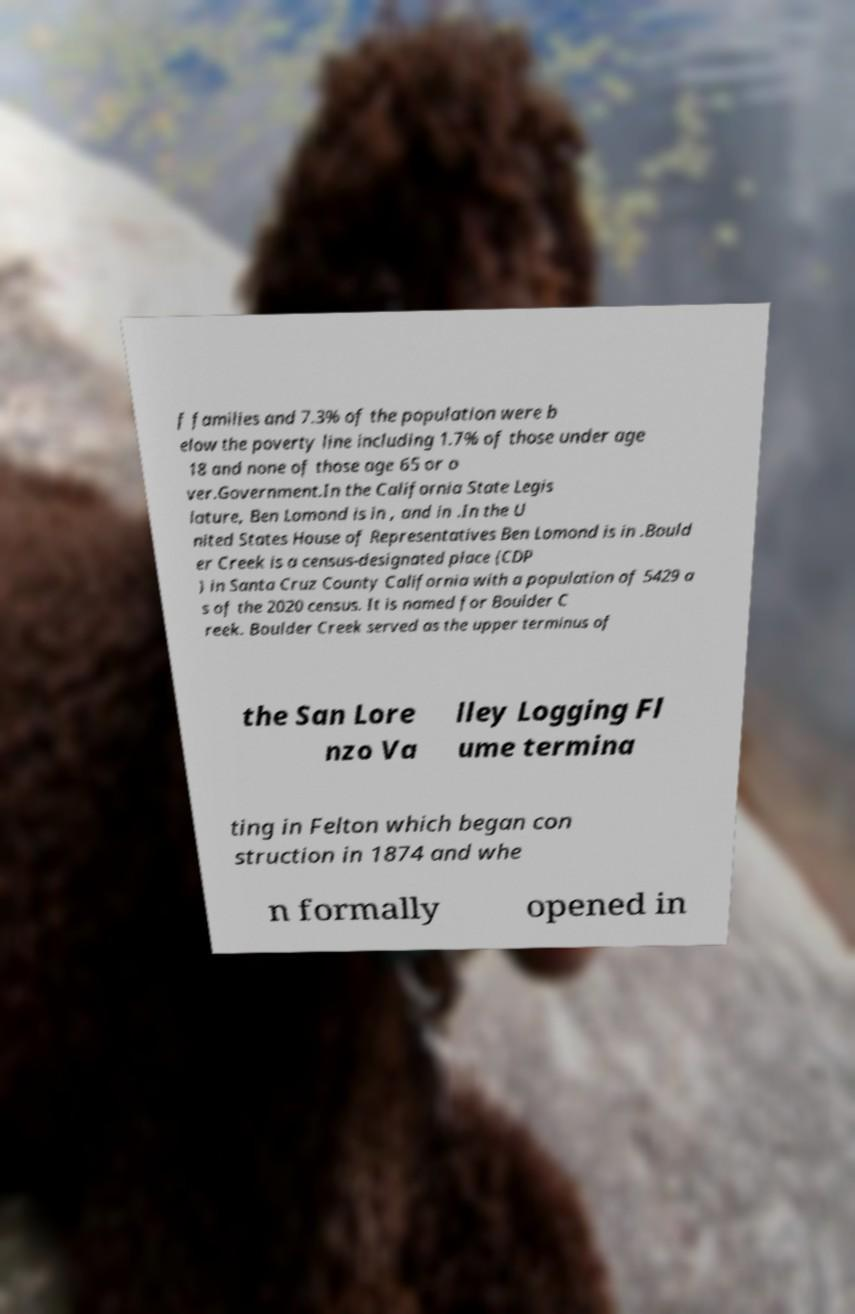Please read and relay the text visible in this image. What does it say? f families and 7.3% of the population were b elow the poverty line including 1.7% of those under age 18 and none of those age 65 or o ver.Government.In the California State Legis lature, Ben Lomond is in , and in .In the U nited States House of Representatives Ben Lomond is in .Bould er Creek is a census-designated place (CDP ) in Santa Cruz County California with a population of 5429 a s of the 2020 census. It is named for Boulder C reek. Boulder Creek served as the upper terminus of the San Lore nzo Va lley Logging Fl ume termina ting in Felton which began con struction in 1874 and whe n formally opened in 